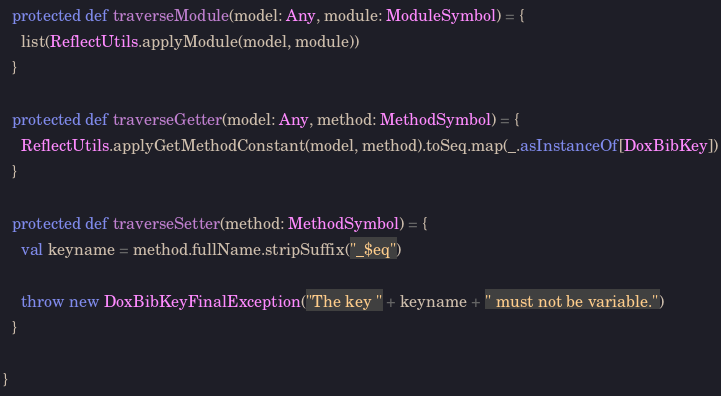<code> <loc_0><loc_0><loc_500><loc_500><_Scala_>
  protected def traverseModule(model: Any, module: ModuleSymbol) = {
    list(ReflectUtils.applyModule(model, module))
  }

  protected def traverseGetter(model: Any, method: MethodSymbol) = {
    ReflectUtils.applyGetMethodConstant(model, method).toSeq.map(_.asInstanceOf[DoxBibKey])
  }

  protected def traverseSetter(method: MethodSymbol) = {
    val keyname = method.fullName.stripSuffix("_$eq")

    throw new DoxBibKeyFinalException("The key " + keyname + " must not be variable.")
  }

}</code> 